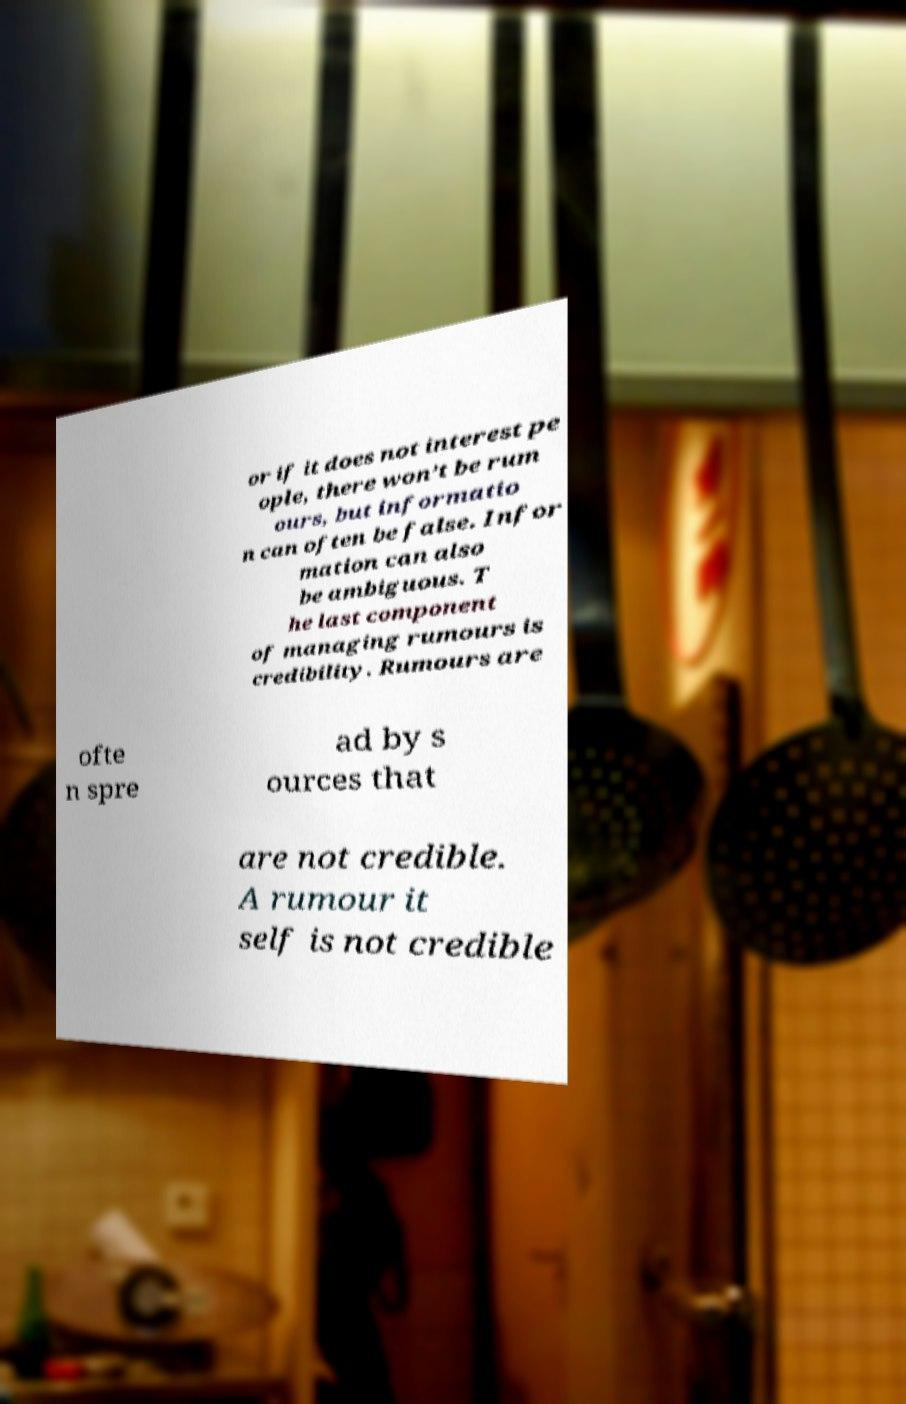Can you accurately transcribe the text from the provided image for me? or if it does not interest pe ople, there won’t be rum ours, but informatio n can often be false. Infor mation can also be ambiguous. T he last component of managing rumours is credibility. Rumours are ofte n spre ad by s ources that are not credible. A rumour it self is not credible 